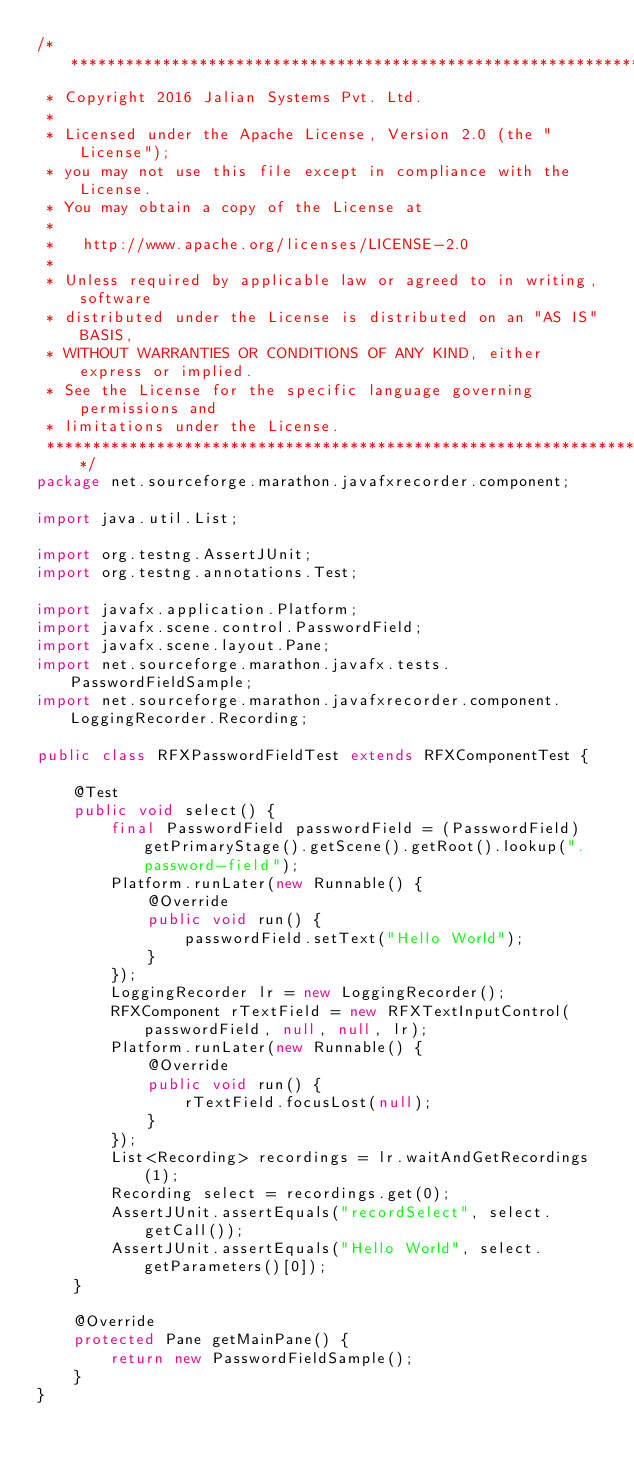<code> <loc_0><loc_0><loc_500><loc_500><_Java_>/*******************************************************************************
 * Copyright 2016 Jalian Systems Pvt. Ltd.
 * 
 * Licensed under the Apache License, Version 2.0 (the "License");
 * you may not use this file except in compliance with the License.
 * You may obtain a copy of the License at
 * 
 *   http://www.apache.org/licenses/LICENSE-2.0
 * 
 * Unless required by applicable law or agreed to in writing, software
 * distributed under the License is distributed on an "AS IS" BASIS,
 * WITHOUT WARRANTIES OR CONDITIONS OF ANY KIND, either express or implied.
 * See the License for the specific language governing permissions and
 * limitations under the License.
 ******************************************************************************/
package net.sourceforge.marathon.javafxrecorder.component;

import java.util.List;

import org.testng.AssertJUnit;
import org.testng.annotations.Test;

import javafx.application.Platform;
import javafx.scene.control.PasswordField;
import javafx.scene.layout.Pane;
import net.sourceforge.marathon.javafx.tests.PasswordFieldSample;
import net.sourceforge.marathon.javafxrecorder.component.LoggingRecorder.Recording;

public class RFXPasswordFieldTest extends RFXComponentTest {

    @Test
    public void select() {
        final PasswordField passwordField = (PasswordField) getPrimaryStage().getScene().getRoot().lookup(".password-field");
        Platform.runLater(new Runnable() {
            @Override
            public void run() {
                passwordField.setText("Hello World");
            }
        });
        LoggingRecorder lr = new LoggingRecorder();
        RFXComponent rTextField = new RFXTextInputControl(passwordField, null, null, lr);
        Platform.runLater(new Runnable() {
            @Override
            public void run() {
                rTextField.focusLost(null);
            }
        });
        List<Recording> recordings = lr.waitAndGetRecordings(1);
        Recording select = recordings.get(0);
        AssertJUnit.assertEquals("recordSelect", select.getCall());
        AssertJUnit.assertEquals("Hello World", select.getParameters()[0]);
    }

    @Override
    protected Pane getMainPane() {
        return new PasswordFieldSample();
    }
}
</code> 